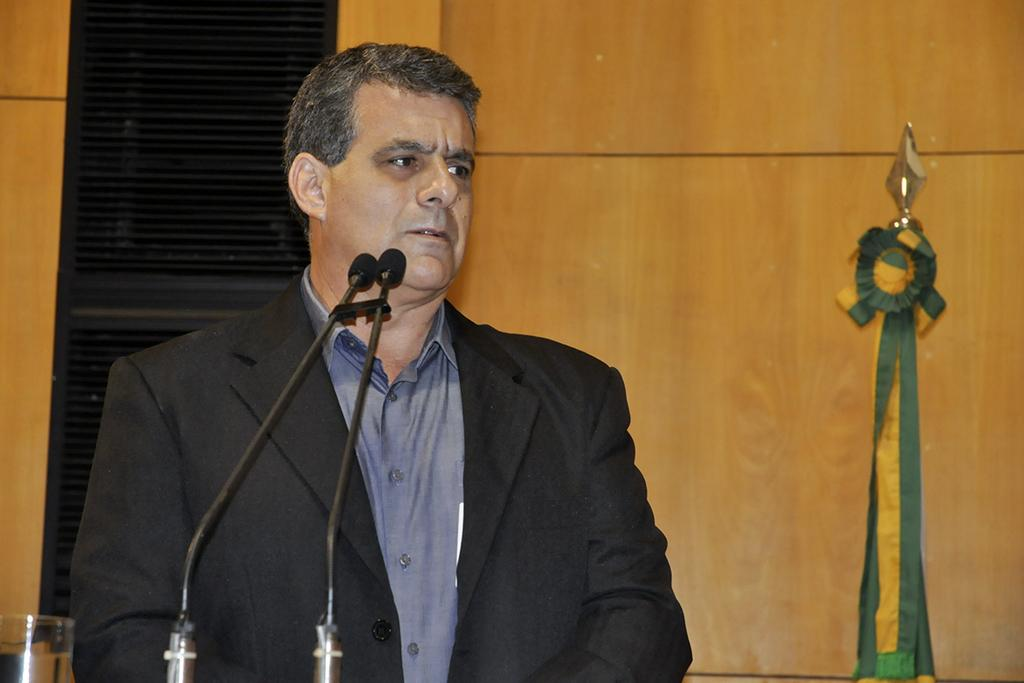Who is present in the image? There is a man in the image. What is the man wearing on his upper body? The man is wearing a blazer and a shirt. What objects can be seen in the image that are related to communication? There are microphones in the image. What type of material can be seen on the wall in the image? There is a wooden wall in the image. What is the glass object in the image used for? The purpose of the glass object in the image cannot be determined from the provided facts. What month is it in the image? The provided facts do not mention any information about the month, so it cannot be determined from the image. What type of music is being played in the image? There is no information about music being played in the image, so it cannot be determined from the provided facts. 